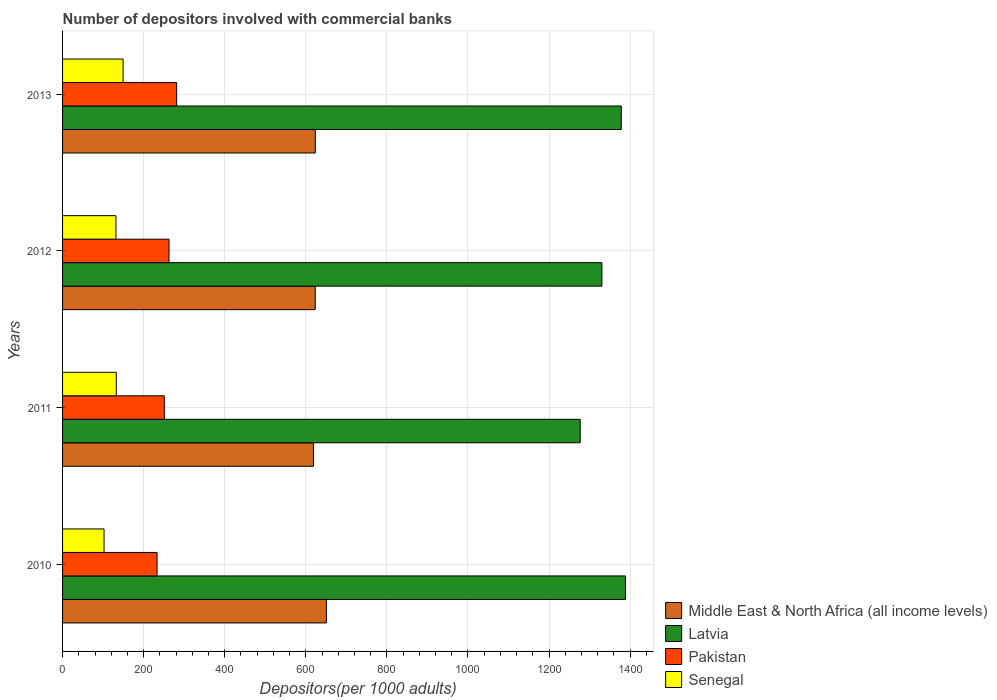Are the number of bars per tick equal to the number of legend labels?
Offer a terse response. Yes. How many bars are there on the 1st tick from the top?
Give a very brief answer. 4. What is the label of the 1st group of bars from the top?
Offer a very short reply. 2013. In how many cases, is the number of bars for a given year not equal to the number of legend labels?
Your answer should be compact. 0. What is the number of depositors involved with commercial banks in Senegal in 2011?
Provide a succinct answer. 132.54. Across all years, what is the maximum number of depositors involved with commercial banks in Senegal?
Your response must be concise. 149.33. Across all years, what is the minimum number of depositors involved with commercial banks in Middle East & North Africa (all income levels)?
Offer a very short reply. 618.84. What is the total number of depositors involved with commercial banks in Latvia in the graph?
Ensure brevity in your answer.  5374.1. What is the difference between the number of depositors involved with commercial banks in Latvia in 2011 and that in 2013?
Ensure brevity in your answer.  -101.32. What is the difference between the number of depositors involved with commercial banks in Latvia in 2010 and the number of depositors involved with commercial banks in Senegal in 2013?
Ensure brevity in your answer.  1239.24. What is the average number of depositors involved with commercial banks in Senegal per year?
Make the answer very short. 128.97. In the year 2012, what is the difference between the number of depositors involved with commercial banks in Latvia and number of depositors involved with commercial banks in Senegal?
Your answer should be compact. 1198.75. In how many years, is the number of depositors involved with commercial banks in Senegal greater than 320 ?
Provide a succinct answer. 0. What is the ratio of the number of depositors involved with commercial banks in Middle East & North Africa (all income levels) in 2011 to that in 2012?
Offer a terse response. 0.99. Is the number of depositors involved with commercial banks in Senegal in 2010 less than that in 2011?
Offer a very short reply. Yes. Is the difference between the number of depositors involved with commercial banks in Latvia in 2012 and 2013 greater than the difference between the number of depositors involved with commercial banks in Senegal in 2012 and 2013?
Your answer should be compact. No. What is the difference between the highest and the second highest number of depositors involved with commercial banks in Latvia?
Offer a very short reply. 10.37. What is the difference between the highest and the lowest number of depositors involved with commercial banks in Latvia?
Your response must be concise. 111.69. Is the sum of the number of depositors involved with commercial banks in Pakistan in 2010 and 2013 greater than the maximum number of depositors involved with commercial banks in Middle East & North Africa (all income levels) across all years?
Give a very brief answer. No. What does the 4th bar from the top in 2013 represents?
Provide a succinct answer. Middle East & North Africa (all income levels). What does the 4th bar from the bottom in 2011 represents?
Provide a succinct answer. Senegal. Are all the bars in the graph horizontal?
Your response must be concise. Yes. How many years are there in the graph?
Your answer should be very brief. 4. Where does the legend appear in the graph?
Your response must be concise. Bottom right. How are the legend labels stacked?
Offer a very short reply. Vertical. What is the title of the graph?
Offer a terse response. Number of depositors involved with commercial banks. Does "Italy" appear as one of the legend labels in the graph?
Provide a short and direct response. No. What is the label or title of the X-axis?
Offer a terse response. Depositors(per 1000 adults). What is the label or title of the Y-axis?
Your answer should be very brief. Years. What is the Depositors(per 1000 adults) in Middle East & North Africa (all income levels) in 2010?
Make the answer very short. 650.77. What is the Depositors(per 1000 adults) in Latvia in 2010?
Offer a very short reply. 1388.57. What is the Depositors(per 1000 adults) of Pakistan in 2010?
Ensure brevity in your answer.  233.11. What is the Depositors(per 1000 adults) of Senegal in 2010?
Ensure brevity in your answer.  102.32. What is the Depositors(per 1000 adults) in Middle East & North Africa (all income levels) in 2011?
Offer a terse response. 618.84. What is the Depositors(per 1000 adults) in Latvia in 2011?
Ensure brevity in your answer.  1276.88. What is the Depositors(per 1000 adults) in Pakistan in 2011?
Keep it short and to the point. 250.99. What is the Depositors(per 1000 adults) in Senegal in 2011?
Your answer should be compact. 132.54. What is the Depositors(per 1000 adults) in Middle East & North Africa (all income levels) in 2012?
Provide a succinct answer. 623.22. What is the Depositors(per 1000 adults) in Latvia in 2012?
Provide a short and direct response. 1330.45. What is the Depositors(per 1000 adults) in Pakistan in 2012?
Provide a short and direct response. 262.6. What is the Depositors(per 1000 adults) in Senegal in 2012?
Offer a terse response. 131.69. What is the Depositors(per 1000 adults) in Middle East & North Africa (all income levels) in 2013?
Make the answer very short. 623.45. What is the Depositors(per 1000 adults) of Latvia in 2013?
Give a very brief answer. 1378.2. What is the Depositors(per 1000 adults) in Pakistan in 2013?
Offer a very short reply. 281.38. What is the Depositors(per 1000 adults) of Senegal in 2013?
Your answer should be compact. 149.33. Across all years, what is the maximum Depositors(per 1000 adults) of Middle East & North Africa (all income levels)?
Provide a short and direct response. 650.77. Across all years, what is the maximum Depositors(per 1000 adults) in Latvia?
Offer a very short reply. 1388.57. Across all years, what is the maximum Depositors(per 1000 adults) of Pakistan?
Your response must be concise. 281.38. Across all years, what is the maximum Depositors(per 1000 adults) in Senegal?
Your answer should be compact. 149.33. Across all years, what is the minimum Depositors(per 1000 adults) in Middle East & North Africa (all income levels)?
Make the answer very short. 618.84. Across all years, what is the minimum Depositors(per 1000 adults) in Latvia?
Offer a terse response. 1276.88. Across all years, what is the minimum Depositors(per 1000 adults) of Pakistan?
Provide a succinct answer. 233.11. Across all years, what is the minimum Depositors(per 1000 adults) of Senegal?
Provide a succinct answer. 102.32. What is the total Depositors(per 1000 adults) in Middle East & North Africa (all income levels) in the graph?
Ensure brevity in your answer.  2516.28. What is the total Depositors(per 1000 adults) of Latvia in the graph?
Provide a succinct answer. 5374.1. What is the total Depositors(per 1000 adults) of Pakistan in the graph?
Offer a very short reply. 1028.08. What is the total Depositors(per 1000 adults) of Senegal in the graph?
Offer a very short reply. 515.89. What is the difference between the Depositors(per 1000 adults) in Middle East & North Africa (all income levels) in 2010 and that in 2011?
Your answer should be very brief. 31.92. What is the difference between the Depositors(per 1000 adults) in Latvia in 2010 and that in 2011?
Make the answer very short. 111.69. What is the difference between the Depositors(per 1000 adults) of Pakistan in 2010 and that in 2011?
Your answer should be compact. -17.88. What is the difference between the Depositors(per 1000 adults) in Senegal in 2010 and that in 2011?
Give a very brief answer. -30.21. What is the difference between the Depositors(per 1000 adults) of Middle East & North Africa (all income levels) in 2010 and that in 2012?
Offer a very short reply. 27.55. What is the difference between the Depositors(per 1000 adults) of Latvia in 2010 and that in 2012?
Offer a very short reply. 58.12. What is the difference between the Depositors(per 1000 adults) of Pakistan in 2010 and that in 2012?
Your response must be concise. -29.49. What is the difference between the Depositors(per 1000 adults) in Senegal in 2010 and that in 2012?
Make the answer very short. -29.37. What is the difference between the Depositors(per 1000 adults) in Middle East & North Africa (all income levels) in 2010 and that in 2013?
Your answer should be very brief. 27.32. What is the difference between the Depositors(per 1000 adults) in Latvia in 2010 and that in 2013?
Your response must be concise. 10.37. What is the difference between the Depositors(per 1000 adults) of Pakistan in 2010 and that in 2013?
Your answer should be very brief. -48.27. What is the difference between the Depositors(per 1000 adults) in Senegal in 2010 and that in 2013?
Provide a short and direct response. -47.01. What is the difference between the Depositors(per 1000 adults) in Middle East & North Africa (all income levels) in 2011 and that in 2012?
Offer a very short reply. -4.38. What is the difference between the Depositors(per 1000 adults) in Latvia in 2011 and that in 2012?
Make the answer very short. -53.57. What is the difference between the Depositors(per 1000 adults) of Pakistan in 2011 and that in 2012?
Provide a short and direct response. -11.61. What is the difference between the Depositors(per 1000 adults) of Senegal in 2011 and that in 2012?
Ensure brevity in your answer.  0.84. What is the difference between the Depositors(per 1000 adults) of Middle East & North Africa (all income levels) in 2011 and that in 2013?
Provide a short and direct response. -4.61. What is the difference between the Depositors(per 1000 adults) in Latvia in 2011 and that in 2013?
Ensure brevity in your answer.  -101.32. What is the difference between the Depositors(per 1000 adults) of Pakistan in 2011 and that in 2013?
Provide a succinct answer. -30.39. What is the difference between the Depositors(per 1000 adults) of Senegal in 2011 and that in 2013?
Keep it short and to the point. -16.8. What is the difference between the Depositors(per 1000 adults) of Middle East & North Africa (all income levels) in 2012 and that in 2013?
Ensure brevity in your answer.  -0.23. What is the difference between the Depositors(per 1000 adults) of Latvia in 2012 and that in 2013?
Ensure brevity in your answer.  -47.75. What is the difference between the Depositors(per 1000 adults) of Pakistan in 2012 and that in 2013?
Ensure brevity in your answer.  -18.78. What is the difference between the Depositors(per 1000 adults) of Senegal in 2012 and that in 2013?
Ensure brevity in your answer.  -17.64. What is the difference between the Depositors(per 1000 adults) of Middle East & North Africa (all income levels) in 2010 and the Depositors(per 1000 adults) of Latvia in 2011?
Your response must be concise. -626.11. What is the difference between the Depositors(per 1000 adults) of Middle East & North Africa (all income levels) in 2010 and the Depositors(per 1000 adults) of Pakistan in 2011?
Keep it short and to the point. 399.77. What is the difference between the Depositors(per 1000 adults) in Middle East & North Africa (all income levels) in 2010 and the Depositors(per 1000 adults) in Senegal in 2011?
Provide a succinct answer. 518.23. What is the difference between the Depositors(per 1000 adults) in Latvia in 2010 and the Depositors(per 1000 adults) in Pakistan in 2011?
Provide a short and direct response. 1137.57. What is the difference between the Depositors(per 1000 adults) in Latvia in 2010 and the Depositors(per 1000 adults) in Senegal in 2011?
Your answer should be very brief. 1256.03. What is the difference between the Depositors(per 1000 adults) of Pakistan in 2010 and the Depositors(per 1000 adults) of Senegal in 2011?
Your answer should be very brief. 100.57. What is the difference between the Depositors(per 1000 adults) in Middle East & North Africa (all income levels) in 2010 and the Depositors(per 1000 adults) in Latvia in 2012?
Provide a succinct answer. -679.68. What is the difference between the Depositors(per 1000 adults) of Middle East & North Africa (all income levels) in 2010 and the Depositors(per 1000 adults) of Pakistan in 2012?
Offer a terse response. 388.17. What is the difference between the Depositors(per 1000 adults) of Middle East & North Africa (all income levels) in 2010 and the Depositors(per 1000 adults) of Senegal in 2012?
Your answer should be very brief. 519.07. What is the difference between the Depositors(per 1000 adults) in Latvia in 2010 and the Depositors(per 1000 adults) in Pakistan in 2012?
Ensure brevity in your answer.  1125.97. What is the difference between the Depositors(per 1000 adults) of Latvia in 2010 and the Depositors(per 1000 adults) of Senegal in 2012?
Ensure brevity in your answer.  1256.87. What is the difference between the Depositors(per 1000 adults) of Pakistan in 2010 and the Depositors(per 1000 adults) of Senegal in 2012?
Provide a short and direct response. 101.42. What is the difference between the Depositors(per 1000 adults) in Middle East & North Africa (all income levels) in 2010 and the Depositors(per 1000 adults) in Latvia in 2013?
Offer a very short reply. -727.44. What is the difference between the Depositors(per 1000 adults) in Middle East & North Africa (all income levels) in 2010 and the Depositors(per 1000 adults) in Pakistan in 2013?
Provide a succinct answer. 369.39. What is the difference between the Depositors(per 1000 adults) of Middle East & North Africa (all income levels) in 2010 and the Depositors(per 1000 adults) of Senegal in 2013?
Provide a succinct answer. 501.43. What is the difference between the Depositors(per 1000 adults) of Latvia in 2010 and the Depositors(per 1000 adults) of Pakistan in 2013?
Provide a succinct answer. 1107.19. What is the difference between the Depositors(per 1000 adults) of Latvia in 2010 and the Depositors(per 1000 adults) of Senegal in 2013?
Provide a short and direct response. 1239.24. What is the difference between the Depositors(per 1000 adults) in Pakistan in 2010 and the Depositors(per 1000 adults) in Senegal in 2013?
Your answer should be very brief. 83.78. What is the difference between the Depositors(per 1000 adults) in Middle East & North Africa (all income levels) in 2011 and the Depositors(per 1000 adults) in Latvia in 2012?
Keep it short and to the point. -711.61. What is the difference between the Depositors(per 1000 adults) of Middle East & North Africa (all income levels) in 2011 and the Depositors(per 1000 adults) of Pakistan in 2012?
Offer a very short reply. 356.24. What is the difference between the Depositors(per 1000 adults) in Middle East & North Africa (all income levels) in 2011 and the Depositors(per 1000 adults) in Senegal in 2012?
Provide a succinct answer. 487.15. What is the difference between the Depositors(per 1000 adults) of Latvia in 2011 and the Depositors(per 1000 adults) of Pakistan in 2012?
Keep it short and to the point. 1014.28. What is the difference between the Depositors(per 1000 adults) in Latvia in 2011 and the Depositors(per 1000 adults) in Senegal in 2012?
Your answer should be compact. 1145.18. What is the difference between the Depositors(per 1000 adults) in Pakistan in 2011 and the Depositors(per 1000 adults) in Senegal in 2012?
Offer a very short reply. 119.3. What is the difference between the Depositors(per 1000 adults) in Middle East & North Africa (all income levels) in 2011 and the Depositors(per 1000 adults) in Latvia in 2013?
Make the answer very short. -759.36. What is the difference between the Depositors(per 1000 adults) in Middle East & North Africa (all income levels) in 2011 and the Depositors(per 1000 adults) in Pakistan in 2013?
Make the answer very short. 337.46. What is the difference between the Depositors(per 1000 adults) of Middle East & North Africa (all income levels) in 2011 and the Depositors(per 1000 adults) of Senegal in 2013?
Your response must be concise. 469.51. What is the difference between the Depositors(per 1000 adults) in Latvia in 2011 and the Depositors(per 1000 adults) in Pakistan in 2013?
Your answer should be compact. 995.5. What is the difference between the Depositors(per 1000 adults) in Latvia in 2011 and the Depositors(per 1000 adults) in Senegal in 2013?
Offer a very short reply. 1127.55. What is the difference between the Depositors(per 1000 adults) of Pakistan in 2011 and the Depositors(per 1000 adults) of Senegal in 2013?
Provide a succinct answer. 101.66. What is the difference between the Depositors(per 1000 adults) in Middle East & North Africa (all income levels) in 2012 and the Depositors(per 1000 adults) in Latvia in 2013?
Your answer should be compact. -754.98. What is the difference between the Depositors(per 1000 adults) in Middle East & North Africa (all income levels) in 2012 and the Depositors(per 1000 adults) in Pakistan in 2013?
Your response must be concise. 341.84. What is the difference between the Depositors(per 1000 adults) in Middle East & North Africa (all income levels) in 2012 and the Depositors(per 1000 adults) in Senegal in 2013?
Offer a very short reply. 473.89. What is the difference between the Depositors(per 1000 adults) in Latvia in 2012 and the Depositors(per 1000 adults) in Pakistan in 2013?
Make the answer very short. 1049.07. What is the difference between the Depositors(per 1000 adults) in Latvia in 2012 and the Depositors(per 1000 adults) in Senegal in 2013?
Your answer should be compact. 1181.12. What is the difference between the Depositors(per 1000 adults) of Pakistan in 2012 and the Depositors(per 1000 adults) of Senegal in 2013?
Make the answer very short. 113.27. What is the average Depositors(per 1000 adults) in Middle East & North Africa (all income levels) per year?
Make the answer very short. 629.07. What is the average Depositors(per 1000 adults) of Latvia per year?
Give a very brief answer. 1343.52. What is the average Depositors(per 1000 adults) of Pakistan per year?
Ensure brevity in your answer.  257.02. What is the average Depositors(per 1000 adults) in Senegal per year?
Make the answer very short. 128.97. In the year 2010, what is the difference between the Depositors(per 1000 adults) in Middle East & North Africa (all income levels) and Depositors(per 1000 adults) in Latvia?
Make the answer very short. -737.8. In the year 2010, what is the difference between the Depositors(per 1000 adults) of Middle East & North Africa (all income levels) and Depositors(per 1000 adults) of Pakistan?
Your answer should be very brief. 417.66. In the year 2010, what is the difference between the Depositors(per 1000 adults) of Middle East & North Africa (all income levels) and Depositors(per 1000 adults) of Senegal?
Your answer should be very brief. 548.44. In the year 2010, what is the difference between the Depositors(per 1000 adults) of Latvia and Depositors(per 1000 adults) of Pakistan?
Keep it short and to the point. 1155.46. In the year 2010, what is the difference between the Depositors(per 1000 adults) of Latvia and Depositors(per 1000 adults) of Senegal?
Offer a terse response. 1286.24. In the year 2010, what is the difference between the Depositors(per 1000 adults) of Pakistan and Depositors(per 1000 adults) of Senegal?
Make the answer very short. 130.78. In the year 2011, what is the difference between the Depositors(per 1000 adults) of Middle East & North Africa (all income levels) and Depositors(per 1000 adults) of Latvia?
Provide a short and direct response. -658.04. In the year 2011, what is the difference between the Depositors(per 1000 adults) in Middle East & North Africa (all income levels) and Depositors(per 1000 adults) in Pakistan?
Your answer should be compact. 367.85. In the year 2011, what is the difference between the Depositors(per 1000 adults) of Middle East & North Africa (all income levels) and Depositors(per 1000 adults) of Senegal?
Your answer should be very brief. 486.31. In the year 2011, what is the difference between the Depositors(per 1000 adults) of Latvia and Depositors(per 1000 adults) of Pakistan?
Provide a short and direct response. 1025.88. In the year 2011, what is the difference between the Depositors(per 1000 adults) of Latvia and Depositors(per 1000 adults) of Senegal?
Offer a terse response. 1144.34. In the year 2011, what is the difference between the Depositors(per 1000 adults) of Pakistan and Depositors(per 1000 adults) of Senegal?
Provide a succinct answer. 118.46. In the year 2012, what is the difference between the Depositors(per 1000 adults) in Middle East & North Africa (all income levels) and Depositors(per 1000 adults) in Latvia?
Ensure brevity in your answer.  -707.23. In the year 2012, what is the difference between the Depositors(per 1000 adults) of Middle East & North Africa (all income levels) and Depositors(per 1000 adults) of Pakistan?
Your answer should be very brief. 360.62. In the year 2012, what is the difference between the Depositors(per 1000 adults) of Middle East & North Africa (all income levels) and Depositors(per 1000 adults) of Senegal?
Your response must be concise. 491.53. In the year 2012, what is the difference between the Depositors(per 1000 adults) of Latvia and Depositors(per 1000 adults) of Pakistan?
Give a very brief answer. 1067.85. In the year 2012, what is the difference between the Depositors(per 1000 adults) in Latvia and Depositors(per 1000 adults) in Senegal?
Offer a very short reply. 1198.75. In the year 2012, what is the difference between the Depositors(per 1000 adults) in Pakistan and Depositors(per 1000 adults) in Senegal?
Provide a succinct answer. 130.9. In the year 2013, what is the difference between the Depositors(per 1000 adults) in Middle East & North Africa (all income levels) and Depositors(per 1000 adults) in Latvia?
Give a very brief answer. -754.75. In the year 2013, what is the difference between the Depositors(per 1000 adults) of Middle East & North Africa (all income levels) and Depositors(per 1000 adults) of Pakistan?
Provide a short and direct response. 342.07. In the year 2013, what is the difference between the Depositors(per 1000 adults) in Middle East & North Africa (all income levels) and Depositors(per 1000 adults) in Senegal?
Your response must be concise. 474.11. In the year 2013, what is the difference between the Depositors(per 1000 adults) of Latvia and Depositors(per 1000 adults) of Pakistan?
Offer a terse response. 1096.82. In the year 2013, what is the difference between the Depositors(per 1000 adults) of Latvia and Depositors(per 1000 adults) of Senegal?
Give a very brief answer. 1228.87. In the year 2013, what is the difference between the Depositors(per 1000 adults) in Pakistan and Depositors(per 1000 adults) in Senegal?
Offer a very short reply. 132.05. What is the ratio of the Depositors(per 1000 adults) in Middle East & North Africa (all income levels) in 2010 to that in 2011?
Offer a terse response. 1.05. What is the ratio of the Depositors(per 1000 adults) in Latvia in 2010 to that in 2011?
Provide a succinct answer. 1.09. What is the ratio of the Depositors(per 1000 adults) in Pakistan in 2010 to that in 2011?
Keep it short and to the point. 0.93. What is the ratio of the Depositors(per 1000 adults) of Senegal in 2010 to that in 2011?
Your answer should be very brief. 0.77. What is the ratio of the Depositors(per 1000 adults) in Middle East & North Africa (all income levels) in 2010 to that in 2012?
Offer a terse response. 1.04. What is the ratio of the Depositors(per 1000 adults) of Latvia in 2010 to that in 2012?
Your answer should be compact. 1.04. What is the ratio of the Depositors(per 1000 adults) of Pakistan in 2010 to that in 2012?
Make the answer very short. 0.89. What is the ratio of the Depositors(per 1000 adults) in Senegal in 2010 to that in 2012?
Your answer should be compact. 0.78. What is the ratio of the Depositors(per 1000 adults) of Middle East & North Africa (all income levels) in 2010 to that in 2013?
Your answer should be compact. 1.04. What is the ratio of the Depositors(per 1000 adults) of Latvia in 2010 to that in 2013?
Provide a short and direct response. 1.01. What is the ratio of the Depositors(per 1000 adults) in Pakistan in 2010 to that in 2013?
Your answer should be compact. 0.83. What is the ratio of the Depositors(per 1000 adults) of Senegal in 2010 to that in 2013?
Make the answer very short. 0.69. What is the ratio of the Depositors(per 1000 adults) of Latvia in 2011 to that in 2012?
Provide a short and direct response. 0.96. What is the ratio of the Depositors(per 1000 adults) of Pakistan in 2011 to that in 2012?
Your response must be concise. 0.96. What is the ratio of the Depositors(per 1000 adults) in Senegal in 2011 to that in 2012?
Your response must be concise. 1.01. What is the ratio of the Depositors(per 1000 adults) in Latvia in 2011 to that in 2013?
Your response must be concise. 0.93. What is the ratio of the Depositors(per 1000 adults) in Pakistan in 2011 to that in 2013?
Your answer should be very brief. 0.89. What is the ratio of the Depositors(per 1000 adults) in Senegal in 2011 to that in 2013?
Your answer should be compact. 0.89. What is the ratio of the Depositors(per 1000 adults) of Latvia in 2012 to that in 2013?
Your answer should be compact. 0.97. What is the ratio of the Depositors(per 1000 adults) of Senegal in 2012 to that in 2013?
Make the answer very short. 0.88. What is the difference between the highest and the second highest Depositors(per 1000 adults) of Middle East & North Africa (all income levels)?
Offer a terse response. 27.32. What is the difference between the highest and the second highest Depositors(per 1000 adults) of Latvia?
Your answer should be compact. 10.37. What is the difference between the highest and the second highest Depositors(per 1000 adults) of Pakistan?
Your answer should be very brief. 18.78. What is the difference between the highest and the second highest Depositors(per 1000 adults) in Senegal?
Keep it short and to the point. 16.8. What is the difference between the highest and the lowest Depositors(per 1000 adults) in Middle East & North Africa (all income levels)?
Provide a succinct answer. 31.92. What is the difference between the highest and the lowest Depositors(per 1000 adults) in Latvia?
Provide a short and direct response. 111.69. What is the difference between the highest and the lowest Depositors(per 1000 adults) of Pakistan?
Your answer should be compact. 48.27. What is the difference between the highest and the lowest Depositors(per 1000 adults) in Senegal?
Give a very brief answer. 47.01. 